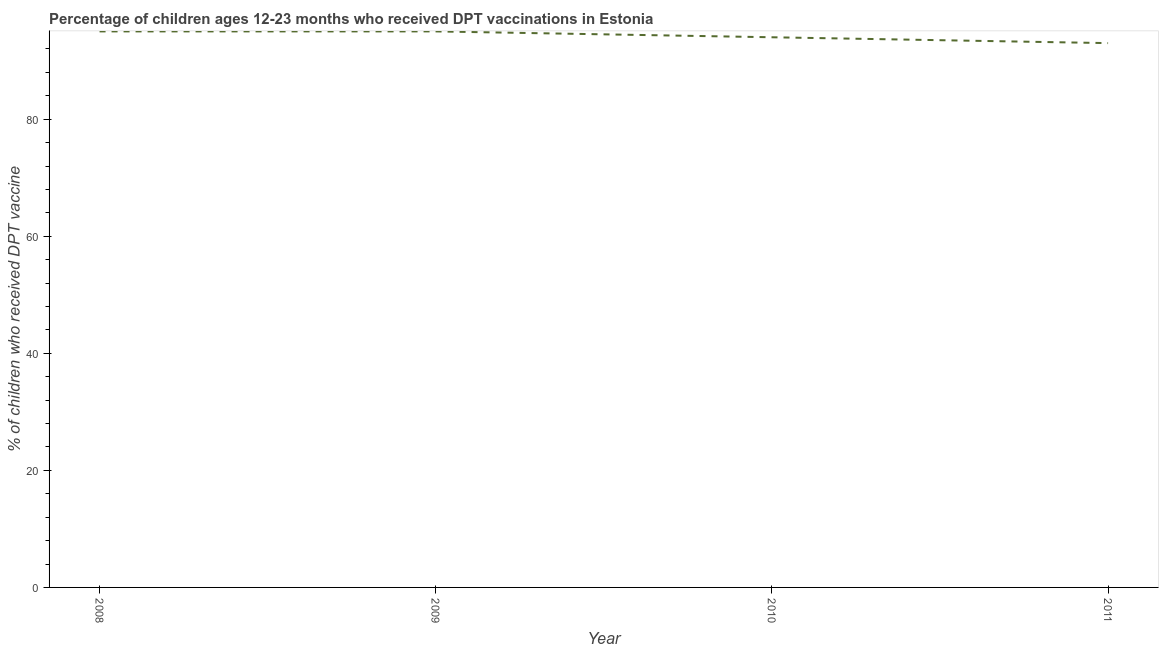What is the percentage of children who received dpt vaccine in 2011?
Your response must be concise. 93. Across all years, what is the maximum percentage of children who received dpt vaccine?
Offer a very short reply. 95. Across all years, what is the minimum percentage of children who received dpt vaccine?
Your answer should be very brief. 93. In which year was the percentage of children who received dpt vaccine maximum?
Your answer should be very brief. 2008. What is the sum of the percentage of children who received dpt vaccine?
Make the answer very short. 377. What is the difference between the percentage of children who received dpt vaccine in 2008 and 2010?
Offer a terse response. 1. What is the average percentage of children who received dpt vaccine per year?
Ensure brevity in your answer.  94.25. What is the median percentage of children who received dpt vaccine?
Make the answer very short. 94.5. In how many years, is the percentage of children who received dpt vaccine greater than 40 %?
Provide a short and direct response. 4. What is the ratio of the percentage of children who received dpt vaccine in 2009 to that in 2010?
Give a very brief answer. 1.01. Is the percentage of children who received dpt vaccine in 2010 less than that in 2011?
Make the answer very short. No. Is the difference between the percentage of children who received dpt vaccine in 2009 and 2011 greater than the difference between any two years?
Your answer should be compact. Yes. Is the sum of the percentage of children who received dpt vaccine in 2009 and 2011 greater than the maximum percentage of children who received dpt vaccine across all years?
Your response must be concise. Yes. What is the difference between the highest and the lowest percentage of children who received dpt vaccine?
Your response must be concise. 2. In how many years, is the percentage of children who received dpt vaccine greater than the average percentage of children who received dpt vaccine taken over all years?
Your answer should be compact. 2. Does the graph contain any zero values?
Your answer should be very brief. No. What is the title of the graph?
Keep it short and to the point. Percentage of children ages 12-23 months who received DPT vaccinations in Estonia. What is the label or title of the X-axis?
Ensure brevity in your answer.  Year. What is the label or title of the Y-axis?
Provide a succinct answer. % of children who received DPT vaccine. What is the % of children who received DPT vaccine in 2010?
Offer a very short reply. 94. What is the % of children who received DPT vaccine in 2011?
Ensure brevity in your answer.  93. What is the difference between the % of children who received DPT vaccine in 2008 and 2011?
Offer a very short reply. 2. What is the difference between the % of children who received DPT vaccine in 2009 and 2010?
Your answer should be compact. 1. What is the ratio of the % of children who received DPT vaccine in 2008 to that in 2011?
Keep it short and to the point. 1.02. What is the ratio of the % of children who received DPT vaccine in 2009 to that in 2011?
Offer a terse response. 1.02. 